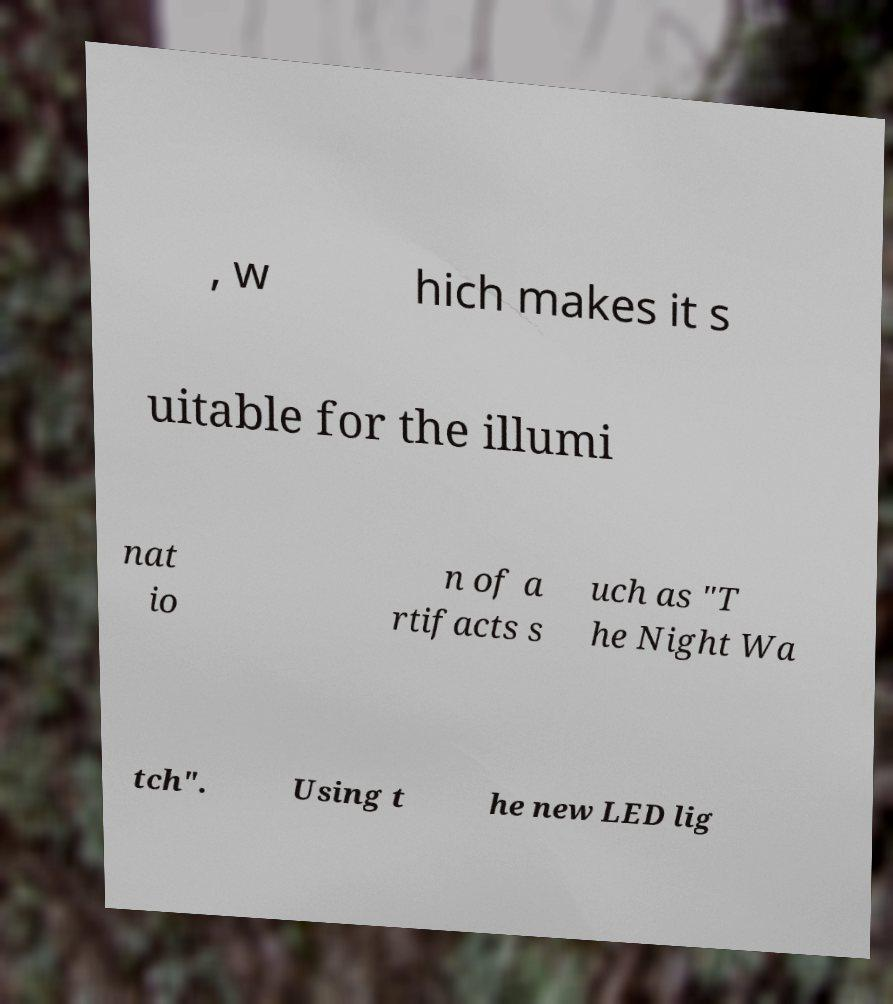Could you assist in decoding the text presented in this image and type it out clearly? , w hich makes it s uitable for the illumi nat io n of a rtifacts s uch as "T he Night Wa tch". Using t he new LED lig 